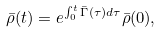<formula> <loc_0><loc_0><loc_500><loc_500>\bar { \rho } ( t ) = e ^ { \int _ { 0 } ^ { t } \bar { \Gamma } ( \tau ) d \tau } \bar { \rho } ( 0 ) ,</formula> 